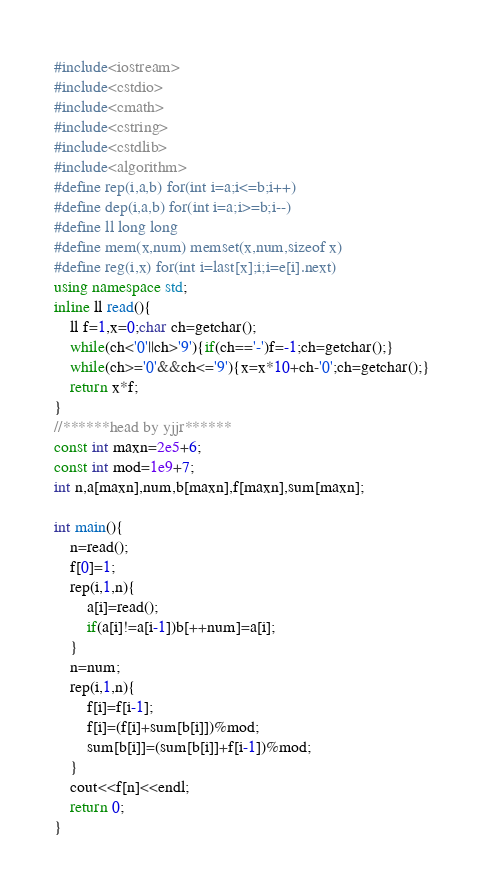<code> <loc_0><loc_0><loc_500><loc_500><_C++_>#include<iostream>
#include<cstdio>
#include<cmath>
#include<cstring>
#include<cstdlib>
#include<algorithm>
#define rep(i,a,b) for(int i=a;i<=b;i++)
#define dep(i,a,b) for(int i=a;i>=b;i--)
#define ll long long
#define mem(x,num) memset(x,num,sizeof x)
#define reg(i,x) for(int i=last[x];i;i=e[i].next)
using namespace std;
inline ll read(){
    ll f=1,x=0;char ch=getchar();
    while(ch<'0'||ch>'9'){if(ch=='-')f=-1;ch=getchar();}
    while(ch>='0'&&ch<='9'){x=x*10+ch-'0';ch=getchar();}
    return x*f;
}
//******head by yjjr******
const int maxn=2e5+6;
const int mod=1e9+7;
int n,a[maxn],num,b[maxn],f[maxn],sum[maxn];

int main(){
    n=read();
    f[0]=1;
    rep(i,1,n){
        a[i]=read();
        if(a[i]!=a[i-1])b[++num]=a[i];
    }
    n=num;
    rep(i,1,n){
        f[i]=f[i-1];
        f[i]=(f[i]+sum[b[i]])%mod;
        sum[b[i]]=(sum[b[i]]+f[i-1])%mod;
    }
    cout<<f[n]<<endl;
    return 0;
}</code> 